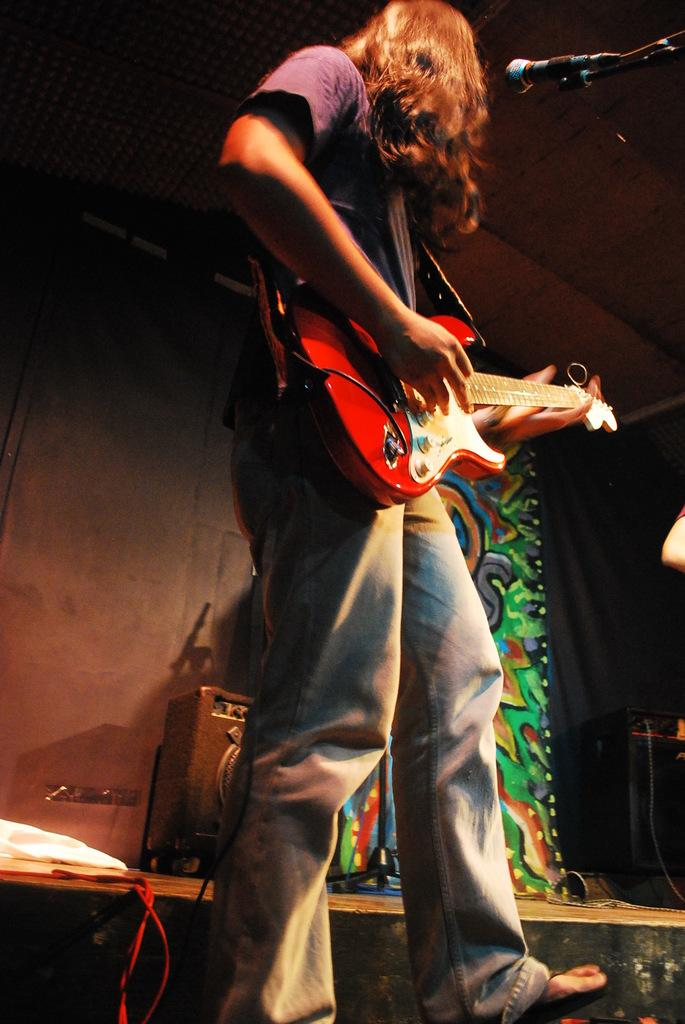What is the man in the image doing? The man is playing the guitar. What object is the man holding in the image? The man is holding a guitar. What is in front of the man that might be used for amplifying his voice? There is a microphone in front of the man. What can be seen in the background of the image? There are speakers and a wall in the background of the image. What type of linen is draped over the speakers in the image? There is no linen draped over the speakers in the image; only the speakers and wall are visible in the background. 